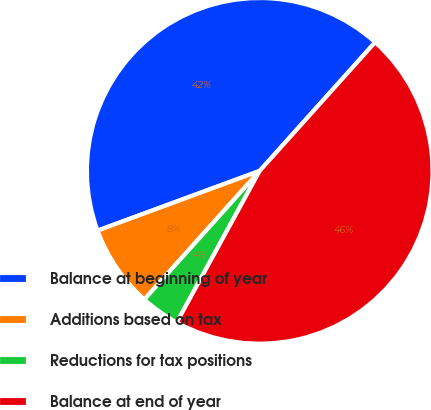Convert chart to OTSL. <chart><loc_0><loc_0><loc_500><loc_500><pie_chart><fcel>Balance at beginning of year<fcel>Additions based on tax<fcel>Reductions for tax positions<fcel>Balance at end of year<nl><fcel>42.26%<fcel>7.74%<fcel>3.67%<fcel>46.33%<nl></chart> 